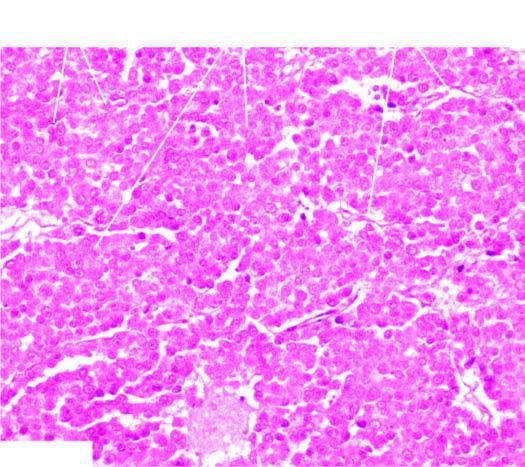re masses of large uniform tumour cells separated by scanty fibrous stroma that is infiltrated by lymphocytes?
Answer the question using a single word or phrase. Yes 